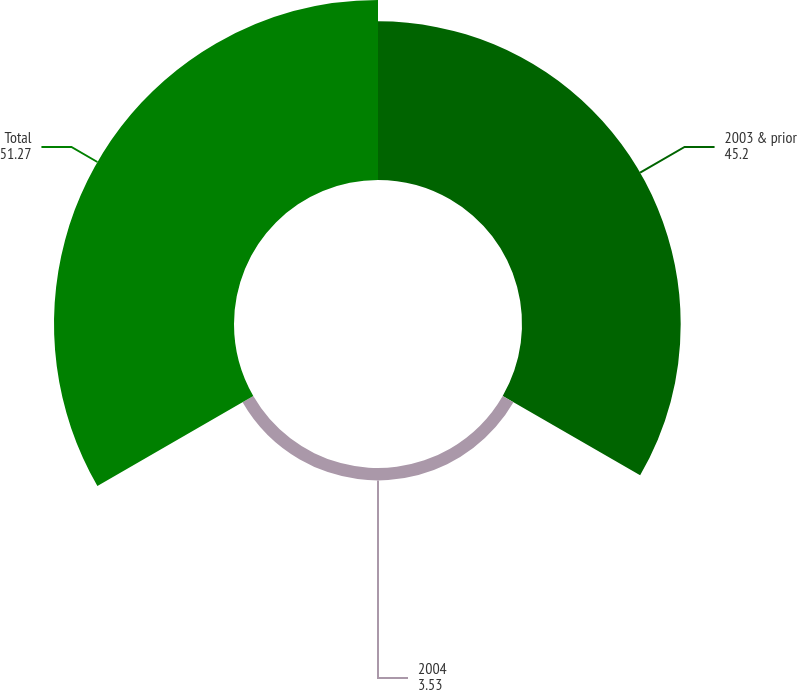Convert chart to OTSL. <chart><loc_0><loc_0><loc_500><loc_500><pie_chart><fcel>2003 & prior<fcel>2004<fcel>Total<nl><fcel>45.2%<fcel>3.53%<fcel>51.27%<nl></chart> 